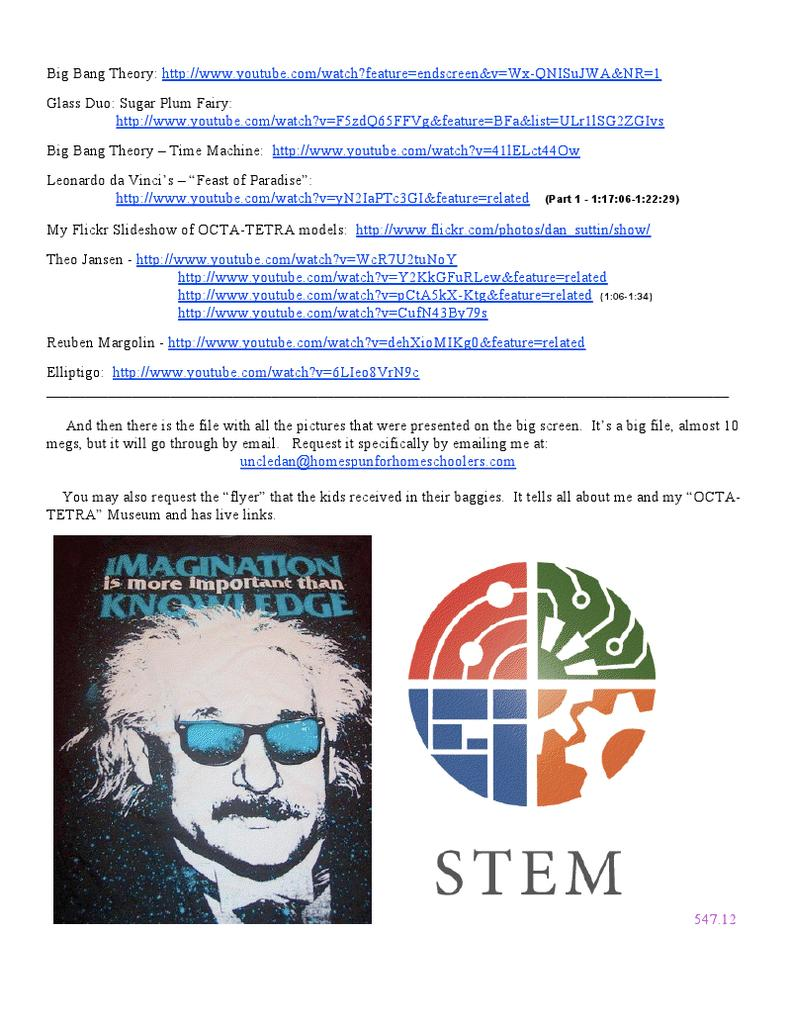What is the main subject of the image? There is a depiction of a person's face in the image. What accessory is the person wearing in the image? The person is wearing shades in the image. What else can be seen in the image besides the person's face? There is text written in multiple places in the image. Is the person skiing down a slope while eating rice in the image? There is no indication of skiing or rice in the image; it only depicts a person's face with shades and text. 